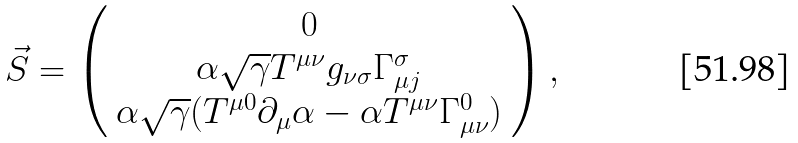Convert formula to latex. <formula><loc_0><loc_0><loc_500><loc_500>\vec { S } = \left ( \begin{array} { c } 0 \\ \alpha \sqrt { \gamma } T ^ { \mu \nu } g _ { \nu \sigma } \Gamma ^ { \sigma } _ { \mu j } \\ \alpha \sqrt { \gamma } ( T ^ { \mu 0 } \partial _ { \mu } \alpha - \alpha T ^ { \mu \nu } \Gamma ^ { 0 } _ { \mu \nu } ) \end{array} \right ) ,</formula> 